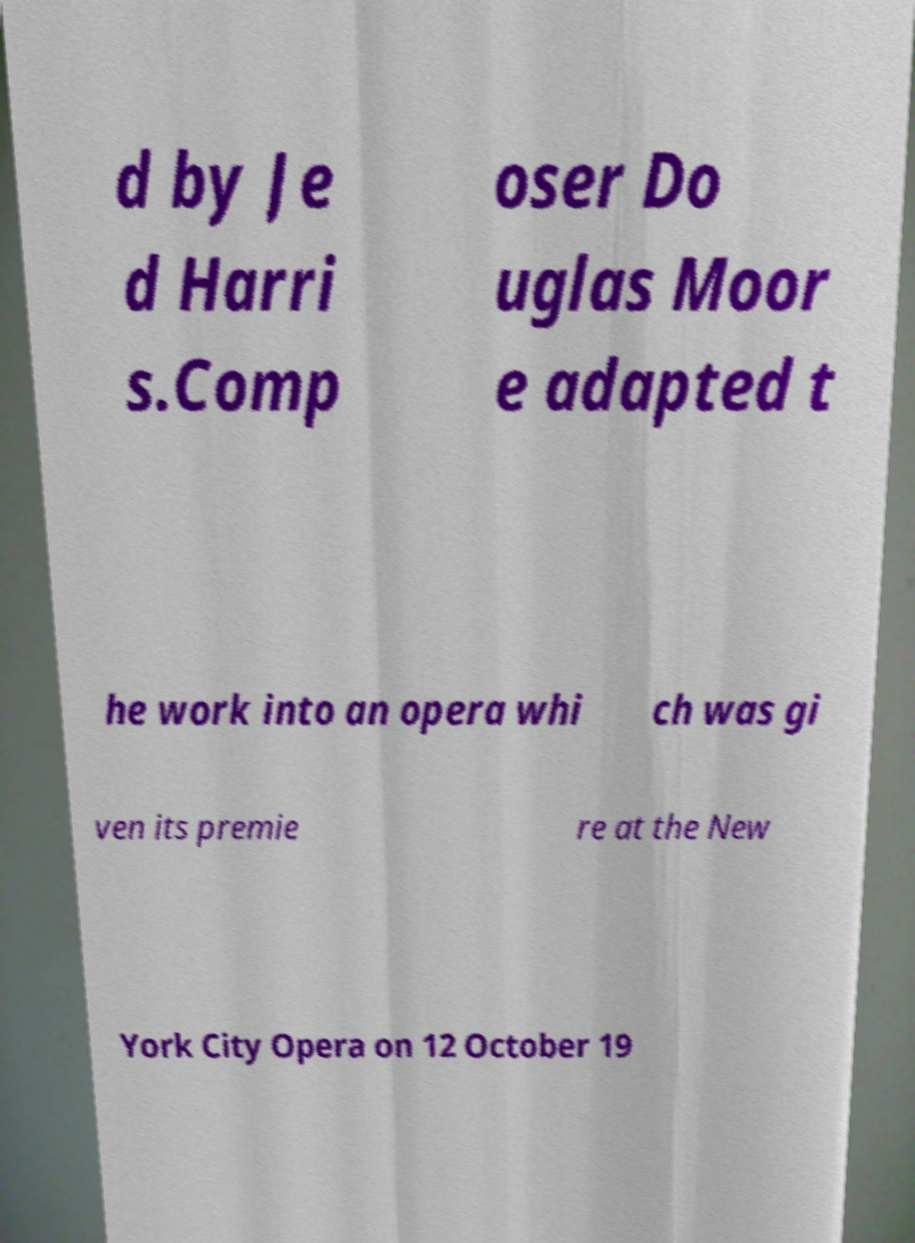There's text embedded in this image that I need extracted. Can you transcribe it verbatim? d by Je d Harri s.Comp oser Do uglas Moor e adapted t he work into an opera whi ch was gi ven its premie re at the New York City Opera on 12 October 19 